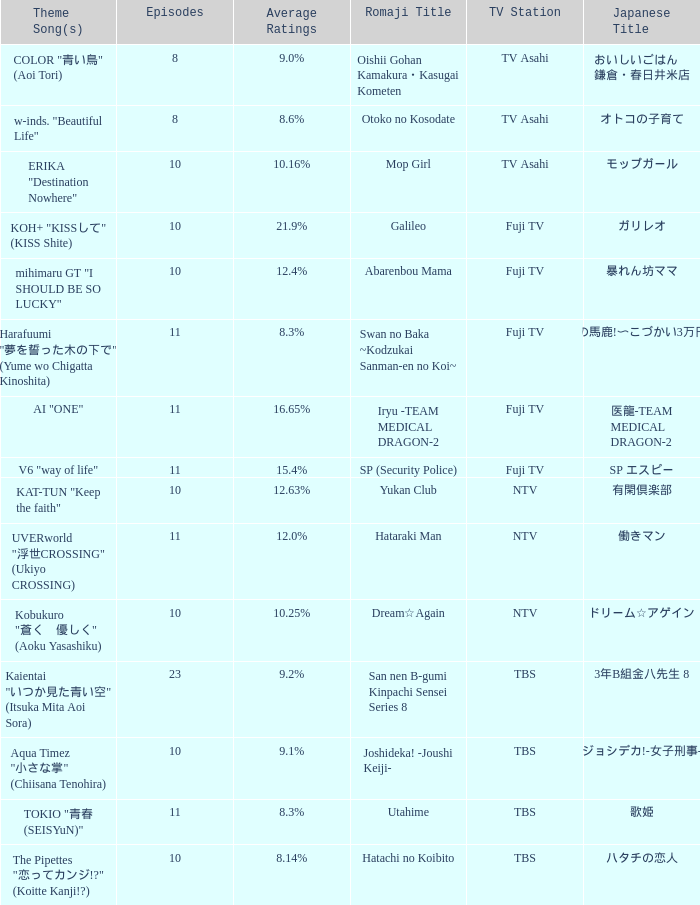What is the Theme Song of 働きマン? UVERworld "浮世CROSSING" (Ukiyo CROSSING). 